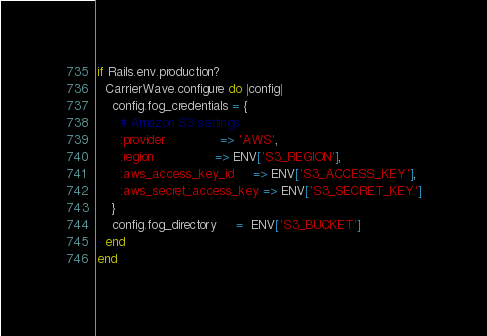Convert code to text. <code><loc_0><loc_0><loc_500><loc_500><_Ruby_>if Rails.env.production?
  CarrierWave.configure do |config|
    config.fog_credentials = {
      # Amazon S3 settings
      :provider              => 'AWS',
      :region                => ENV['S3_REGION'],
      :aws_access_key_id     => ENV['S3_ACCESS_KEY'],
      :aws_secret_access_key => ENV['S3_SECRET_KEY']
    }
    config.fog_directory     =  ENV['S3_BUCKET']
  end
end
</code> 